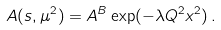Convert formula to latex. <formula><loc_0><loc_0><loc_500><loc_500>A ( s , \mu ^ { 2 } ) = A ^ { B } \exp ( - \lambda Q ^ { 2 } x ^ { 2 } ) \, .</formula> 